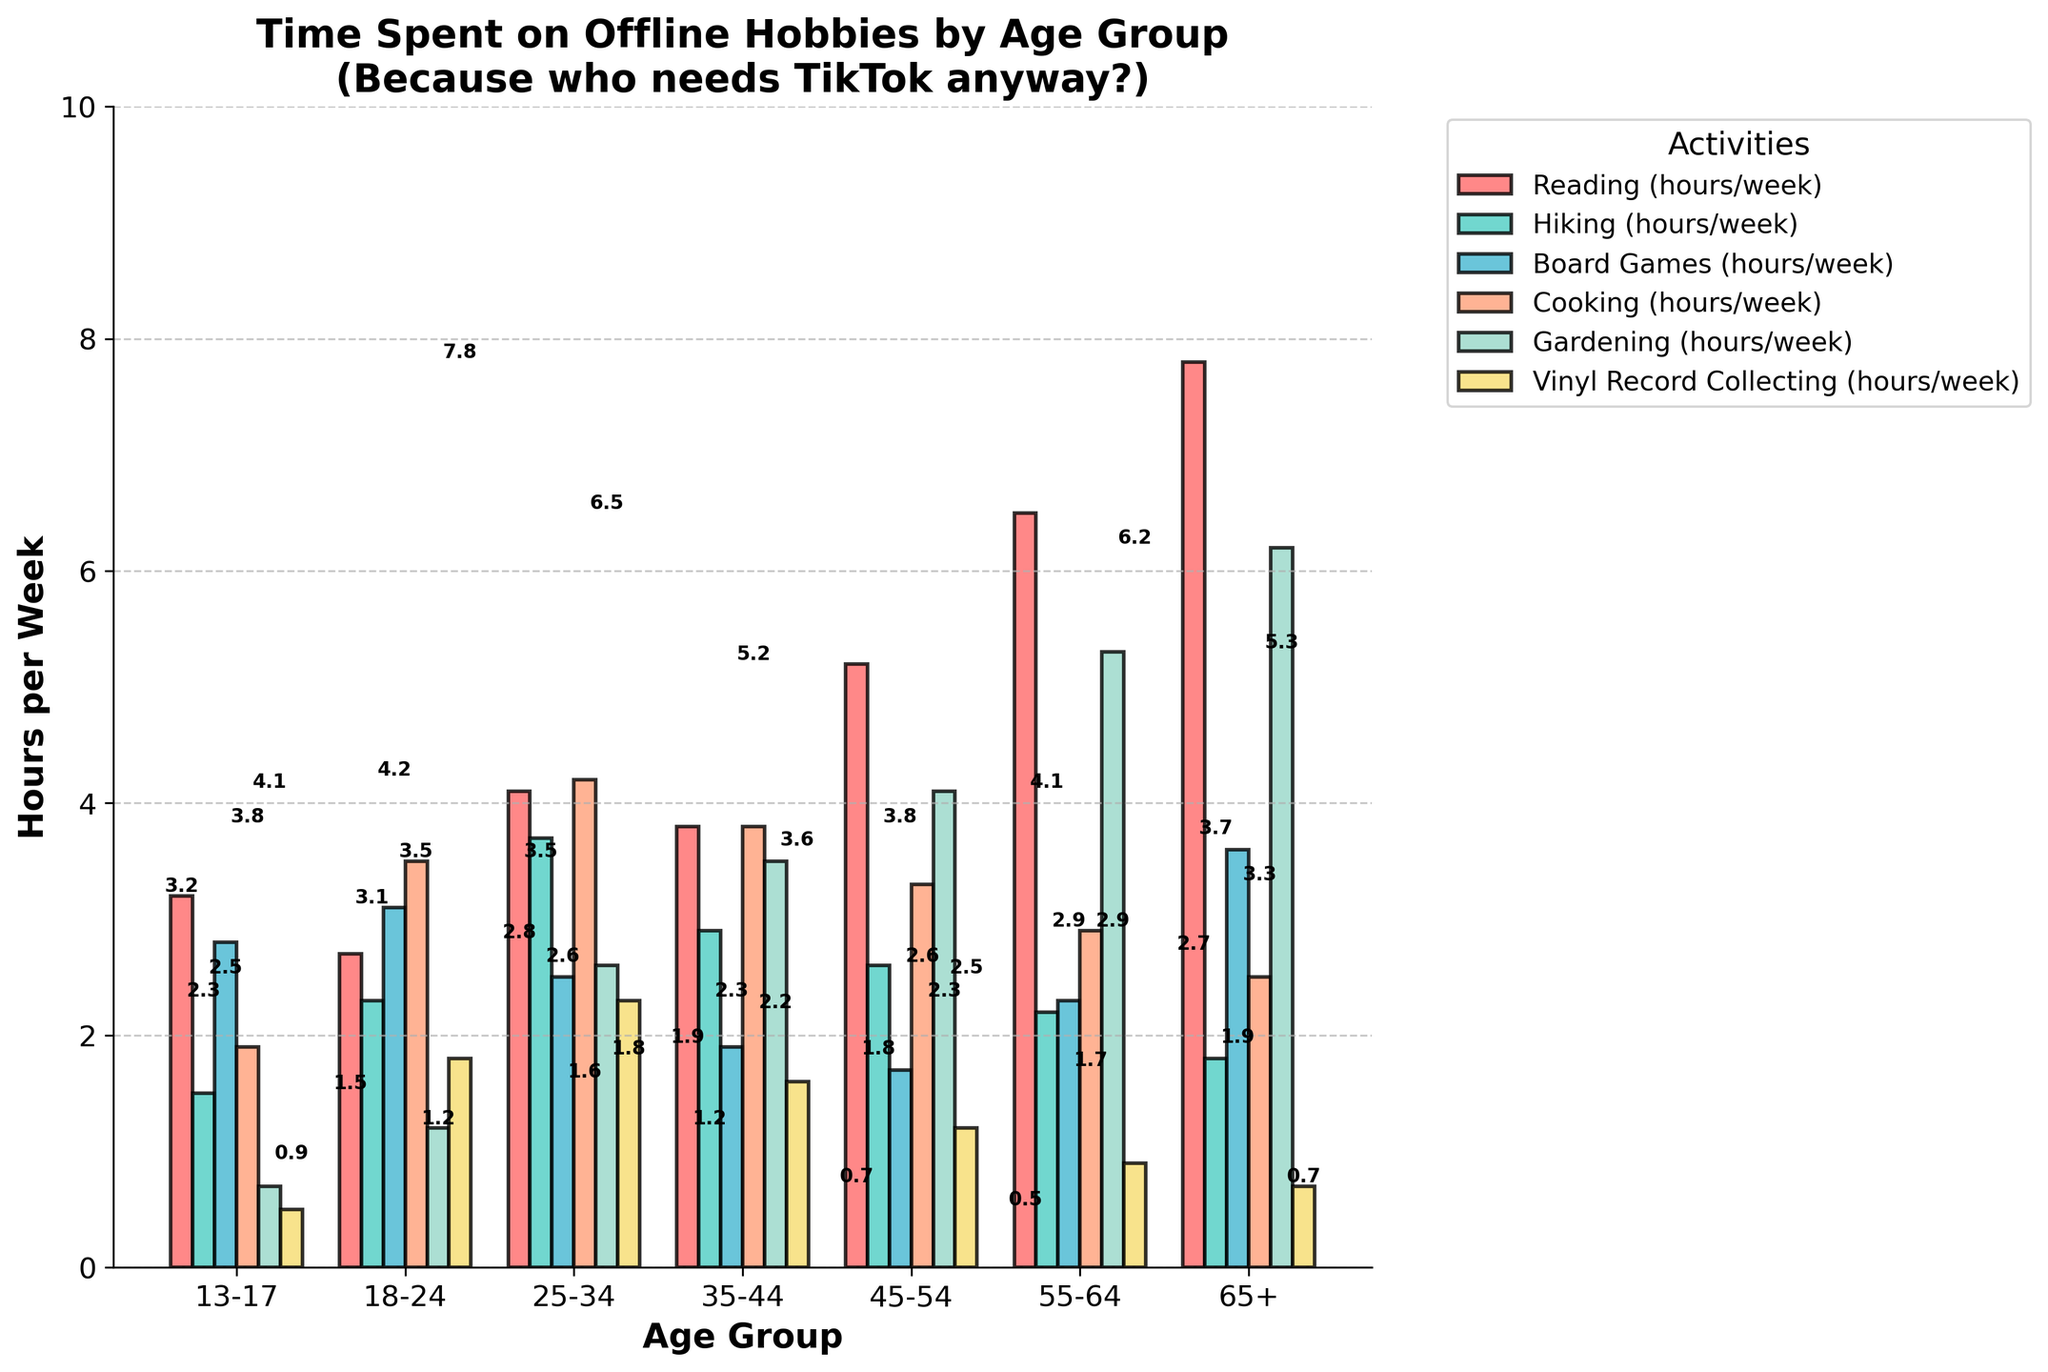What's the average time spent on reading by all age groups? To find the average, add all the reading times for each age group and divide by the number of age groups: (3.2 + 2.7 + 4.1 + 3.8 + 5.2 + 6.5 + 7.8) / 7 = 33.3 / 7 = 4.76
Answer: 4.76 Which age group spends the most and the least time on hiking? Compare the hiking times for each age group. Most time: 25-34 (3.7 hours). Least time: 13-17 (1.5 hours)
Answer: Most: 25-34, Least: 13-17 How much more time does the 65+ group spend on gardening compared to the 18-24 group? Subtract the gardening time of the 18-24 group from the 65+ group: 6.2 - 1.2 = 5.0 hours
Answer: 5.0 hours In which age group is the time spent on board games equal to the time spent on cooking? Compare the values for board games and cooking by each age group. Only the 18-24 group has equal time: 3.1 hours each
Answer: 18-24 Which hobby has the lowest total time spent across all age groups? Sum the times for each hobby across all age groups and compare. Vinyl Record Collecting: 0.5 + 1.8 + 2.3 + 1.6 + 1.2 + 0.9 + 0.7 = 9.0 hours, which is the lowest
Answer: Vinyl Record Collecting Is there any age group where the time spent on reading is more than the combined time for hiking and board games? Calculate and compare for each age group. For 55-64: Reading (6.5) vs. Hiking+Board Games (2.2+2.3=4.5) and others similarly. Yes, 55-64 has 6.5 reading versus 4.5 combined
Answer: Yes, 55-64 Which activity has the highest average time across all age groups? Calculate the average time per age group for each activity. Reading: (3.2 + 2.7 + 4.1 + 3.8 + 5.2 + 6.5 + 7.8) / 7 = 4.76, others similarly. Reading has the highest average.
Answer: Reading What’s the difference between the time spent on cooking and gardening for the age group 35-44? Subtract the time spent on gardening from cooking: 3.8 - 3.5 = 0.3 hours
Answer: 0.3 hours Which age group spends nearly equal time on all activities? Check each age group for near-equal values in different categories. The 18-24 group has relatively balanced times (except a higher time on cooking) compared to other age groups
Answer: 18-24 